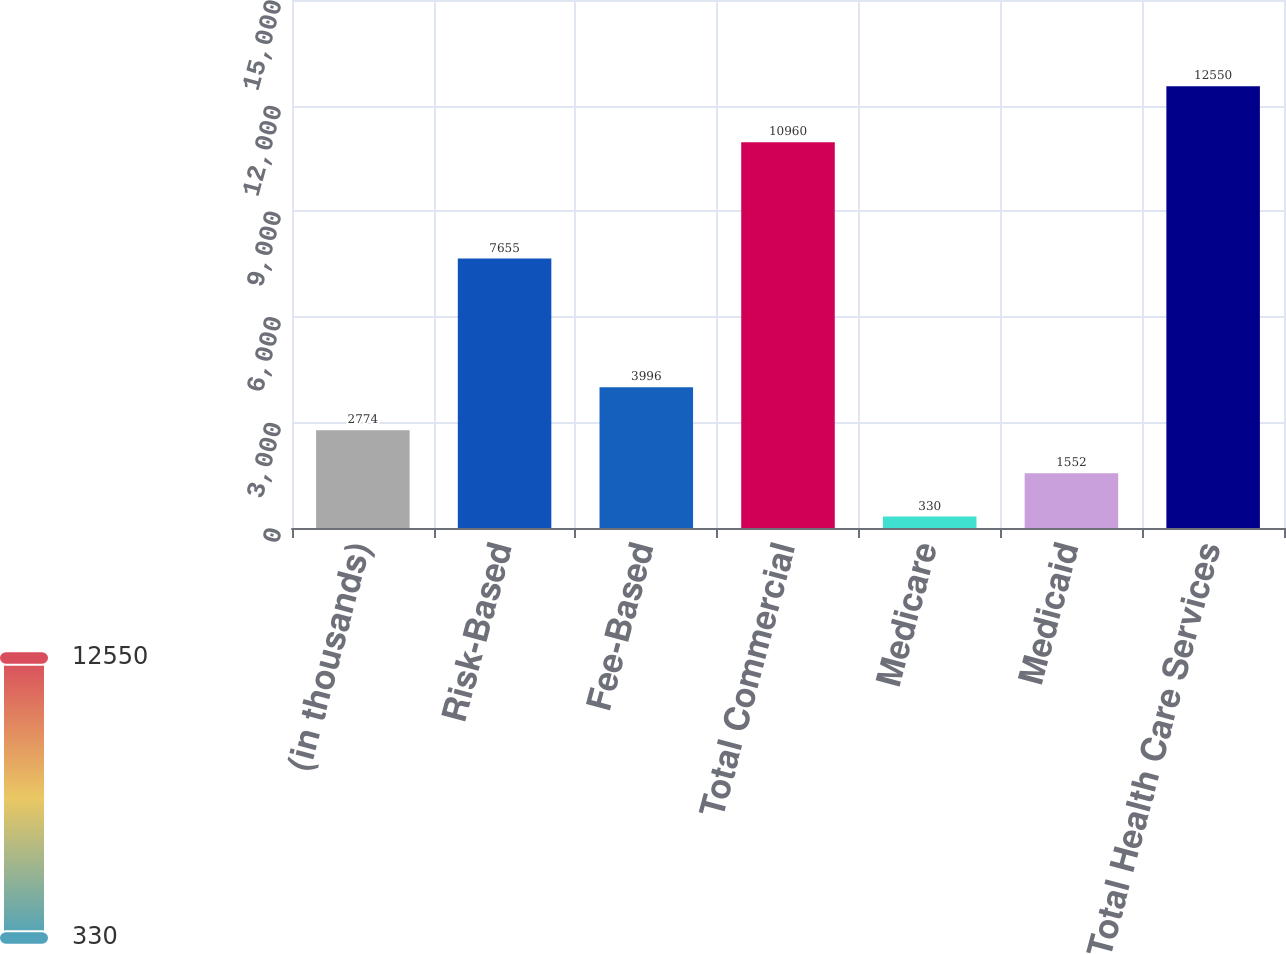Convert chart. <chart><loc_0><loc_0><loc_500><loc_500><bar_chart><fcel>(in thousands)<fcel>Risk-Based<fcel>Fee-Based<fcel>Total Commercial<fcel>Medicare<fcel>Medicaid<fcel>Total Health Care Services<nl><fcel>2774<fcel>7655<fcel>3996<fcel>10960<fcel>330<fcel>1552<fcel>12550<nl></chart> 